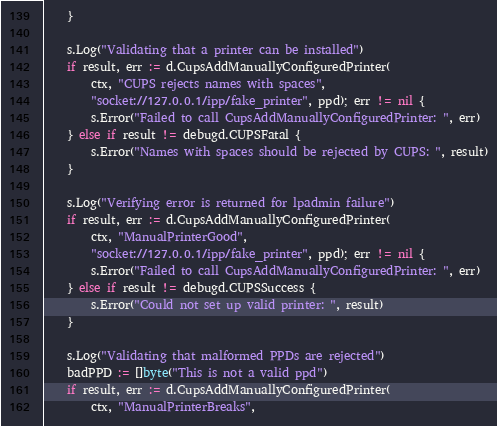<code> <loc_0><loc_0><loc_500><loc_500><_Go_>	}

	s.Log("Validating that a printer can be installed")
	if result, err := d.CupsAddManuallyConfiguredPrinter(
		ctx, "CUPS rejects names with spaces",
		"socket://127.0.0.1/ipp/fake_printer", ppd); err != nil {
		s.Error("Failed to call CupsAddManuallyConfiguredPrinter: ", err)
	} else if result != debugd.CUPSFatal {
		s.Error("Names with spaces should be rejected by CUPS: ", result)
	}

	s.Log("Verifying error is returned for lpadmin failure")
	if result, err := d.CupsAddManuallyConfiguredPrinter(
		ctx, "ManualPrinterGood",
		"socket://127.0.0.1/ipp/fake_printer", ppd); err != nil {
		s.Error("Failed to call CupsAddManuallyConfiguredPrinter: ", err)
	} else if result != debugd.CUPSSuccess {
		s.Error("Could not set up valid printer: ", result)
	}

	s.Log("Validating that malformed PPDs are rejected")
	badPPD := []byte("This is not a valid ppd")
	if result, err := d.CupsAddManuallyConfiguredPrinter(
		ctx, "ManualPrinterBreaks",</code> 